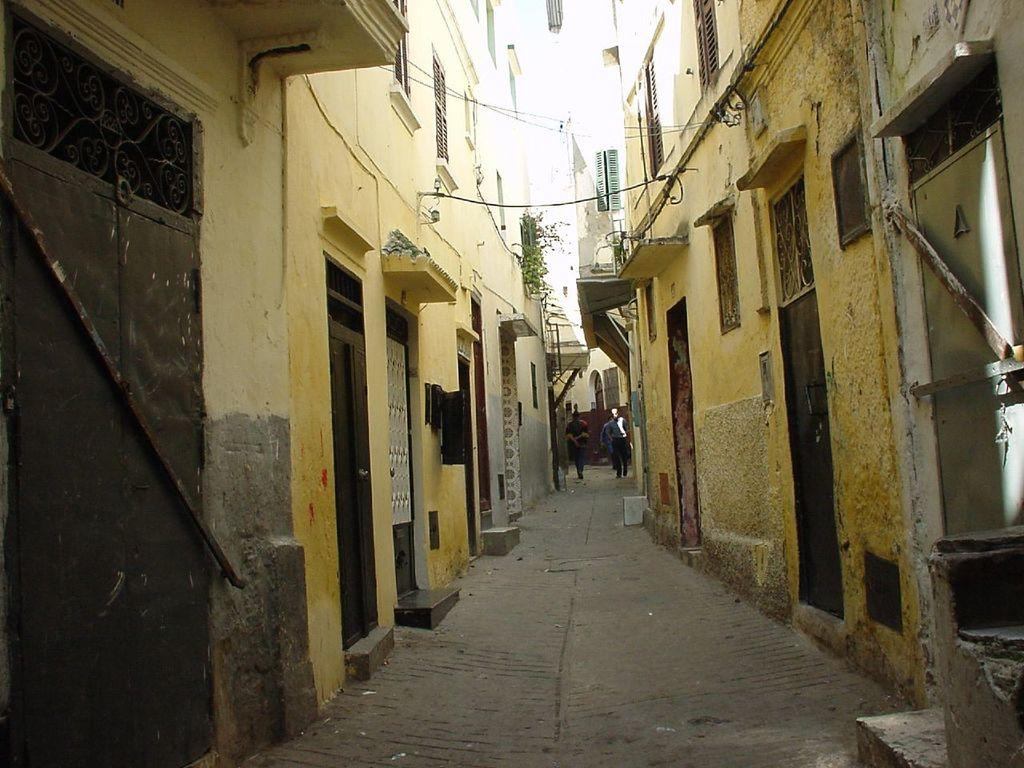What is the main feature in the middle of the image? There is a path in the middle of the image. What are the people in the image doing? There are people moving on the path. What can be seen on both sides of the path? There are buildings on both sides of the path. What features can be observed in the buildings? There are doors and windows in the buildings. How many thumbs can be seen supporting the buildings in the image? There are no thumbs visible in the image, and they are not supporting the buildings. 